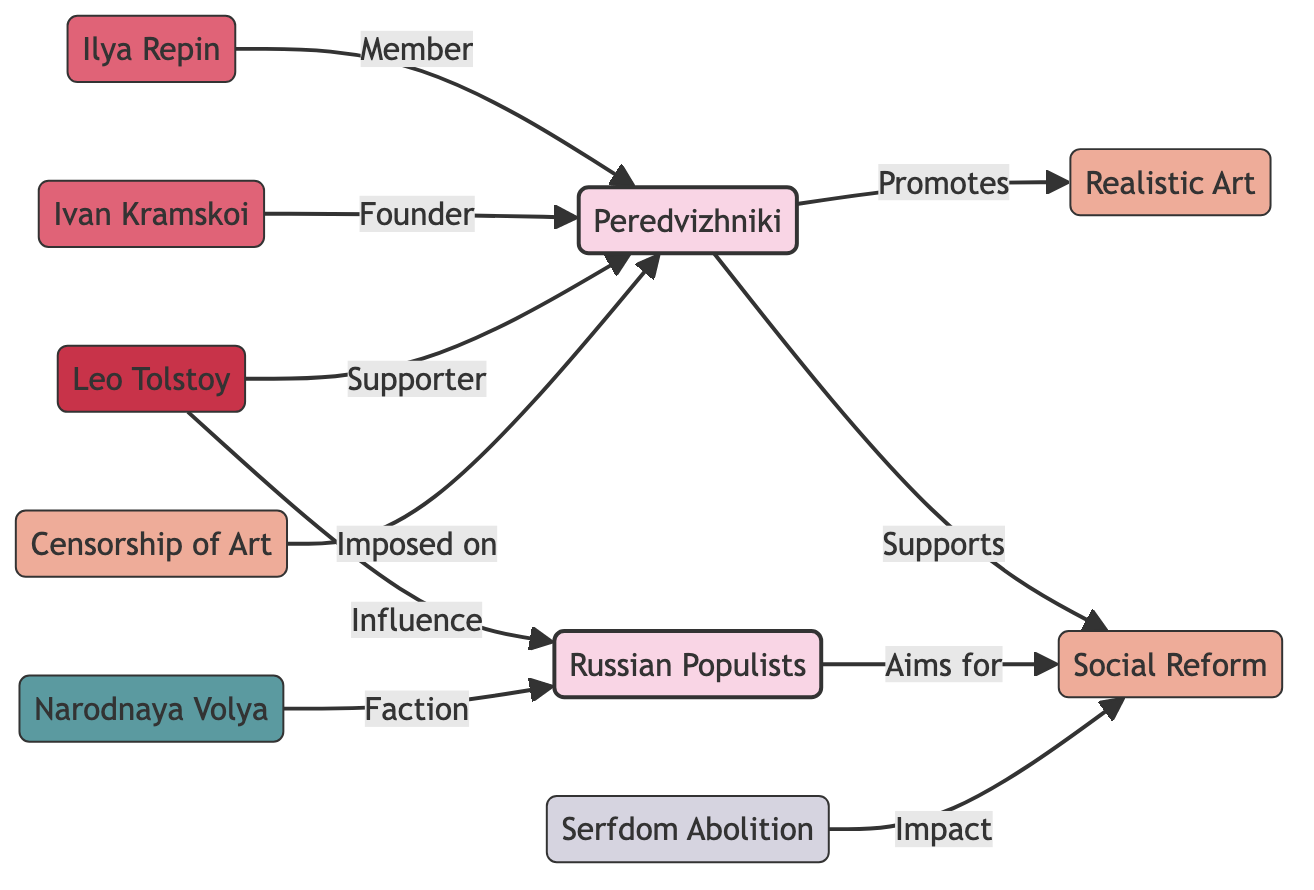What is the total number of nodes in the diagram? The diagram includes nodes representing groups, concepts, individual artists, and organizations. They can be counted individually: Peredvizhniki, Russian Populists, Realistic Art, Social Reform, Ilya Repin, Ivan Kramskoi, Leo Tolstoy, Narodnaya Volya, Censorship of Art, and Serfdom Abolition. This totals 10 nodes.
Answer: 10 Which artist is labeled as a founder of the Peredvizhniki? In the edges connecting to the Peredvizhniki, the edge from Ivan Kramskoi is labeled "Founder." Therefore, he is identified as the founder.
Answer: Ivan Kramskoi How many relationships does the node 'Peredvizhniki' have? The node 'Peredvizhniki' has four direct relationships: promotes Realistic Art, supports Social Reform, has Ilya Repin as a member, and has Ivan Kramskoi as a founder. Counting these relationships gives a total of four.
Answer: 4 Which organization is connected to the Russian Populists as a faction? The node Narodnaya Volya is labeled as a faction of the Russian Populists. It shows a direct connection meaning it influences or is part of that group.
Answer: Narodnaya Volya What concept is impacted by the event of serfdom abolition? The edge shows that the event 'Serfdom Abolition' has an "Impact" on the concept 'Social Reform.' Therefore, this indicates a direct relationship where the abolition influences social reform efforts.
Answer: Social Reform Who is identified as a supporter of the Peredvizhniki? The artist Leo Tolstoy is indicated as a "Supporter" of the Peredvizhniki in the edges connecting the respective nodes.
Answer: Leo Tolstoy What type of restriction is imposed on the Peredvizhniki? The concept 'Censorship of Art' is noted as being "Imposed on" the Peredvizhniki, indicating a limitation or restriction placed upon them in their artistic endeavors.
Answer: Censorship of Art Which two nodes are associated with the concept of Social Reform? The nodes connected to the concept of Social Reform are 'Peredvizhniki' and 'Russian Populists.' Both groups aim for or support this reform as indicated in the diagram.
Answer: Peredvizhniki, Russian Populists What influence does Leo Tolstoy have on the Russian Populists? The diagram indicates that Leo Tolstoy has the relationship of "Influence" on the Russian Populists, suggesting he plays a role in shaping or aiding their ideologies or goals.
Answer: Influence How does the Russian Populists relate to social reform? The edge shows that the Russian Populists "Aims for" social reform, indicating their goals align with the pursuit of social reform initiatives.
Answer: Aims for 